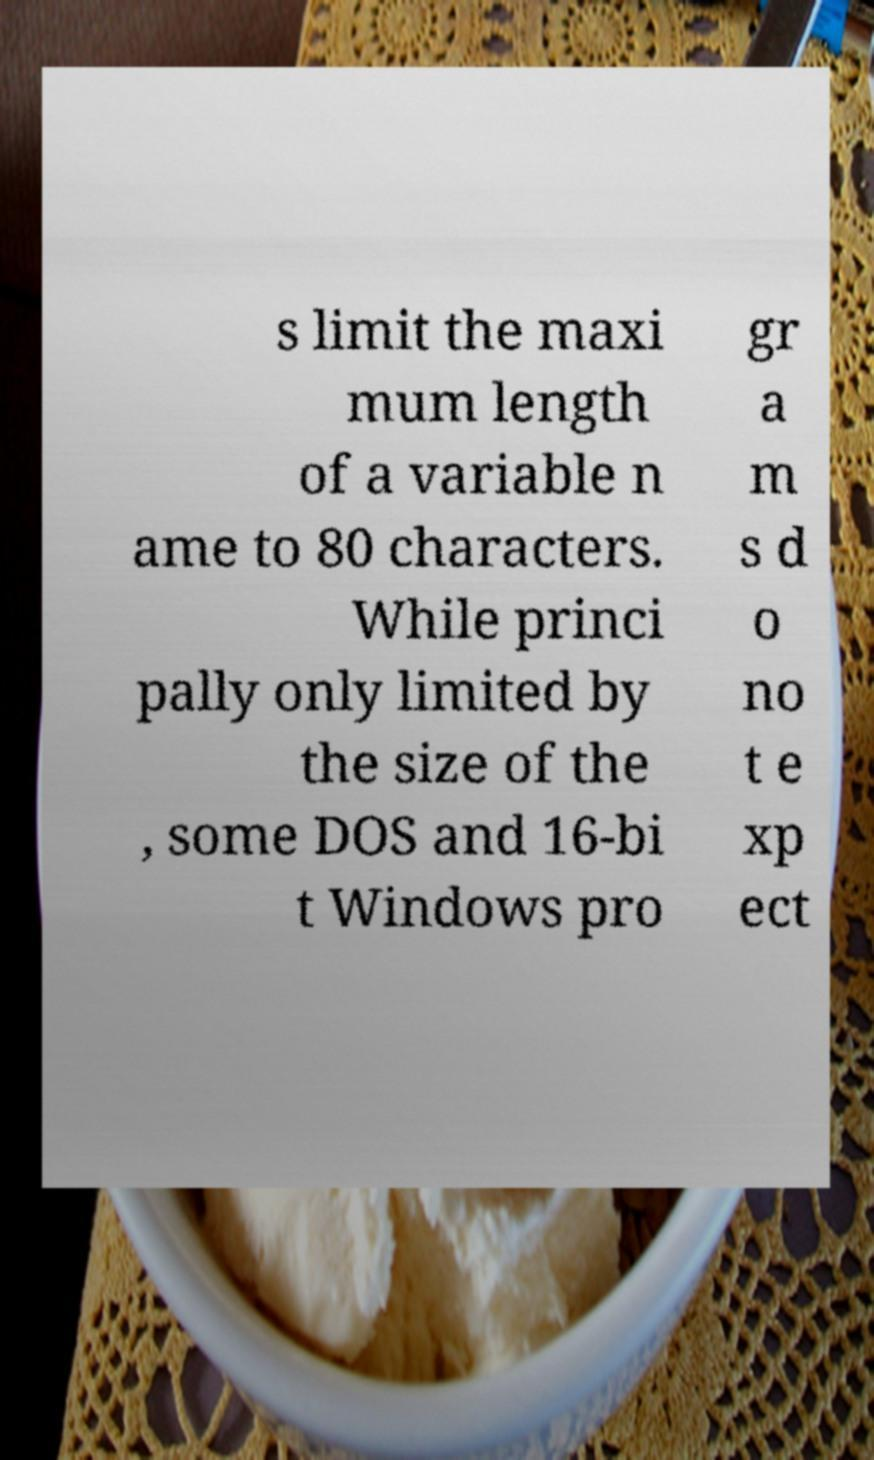Please read and relay the text visible in this image. What does it say? s limit the maxi mum length of a variable n ame to 80 characters. While princi pally only limited by the size of the , some DOS and 16-bi t Windows pro gr a m s d o no t e xp ect 